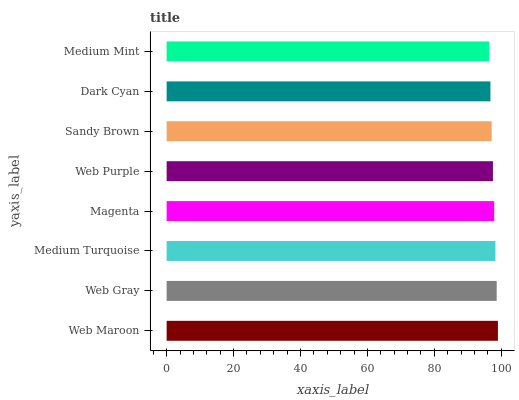Is Medium Mint the minimum?
Answer yes or no. Yes. Is Web Maroon the maximum?
Answer yes or no. Yes. Is Web Gray the minimum?
Answer yes or no. No. Is Web Gray the maximum?
Answer yes or no. No. Is Web Maroon greater than Web Gray?
Answer yes or no. Yes. Is Web Gray less than Web Maroon?
Answer yes or no. Yes. Is Web Gray greater than Web Maroon?
Answer yes or no. No. Is Web Maroon less than Web Gray?
Answer yes or no. No. Is Magenta the high median?
Answer yes or no. Yes. Is Web Purple the low median?
Answer yes or no. Yes. Is Web Gray the high median?
Answer yes or no. No. Is Dark Cyan the low median?
Answer yes or no. No. 